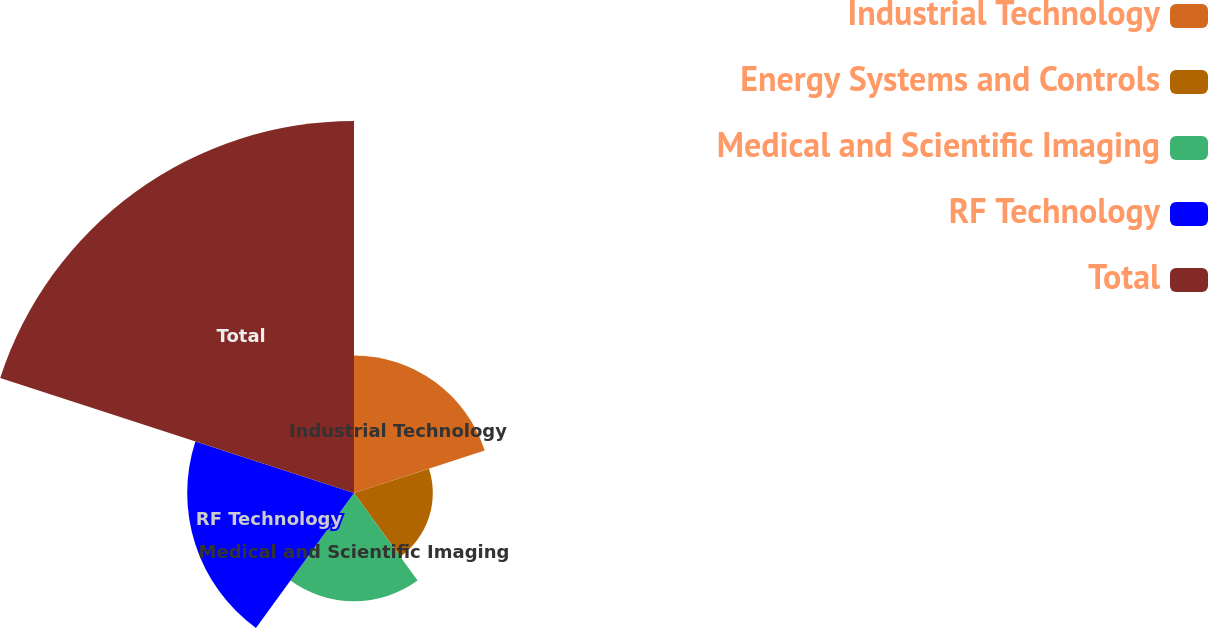Convert chart. <chart><loc_0><loc_0><loc_500><loc_500><pie_chart><fcel>Industrial Technology<fcel>Energy Systems and Controls<fcel>Medical and Scientific Imaging<fcel>RF Technology<fcel>Total<nl><fcel>15.92%<fcel>9.13%<fcel>12.53%<fcel>19.32%<fcel>43.09%<nl></chart> 